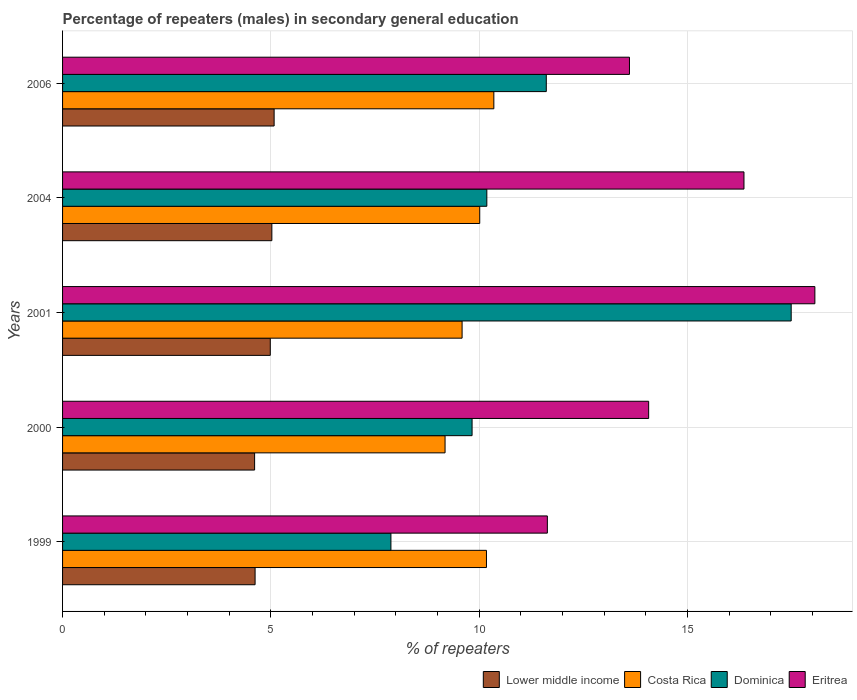How many groups of bars are there?
Your response must be concise. 5. Are the number of bars per tick equal to the number of legend labels?
Your answer should be very brief. Yes. How many bars are there on the 4th tick from the top?
Provide a short and direct response. 4. In how many cases, is the number of bars for a given year not equal to the number of legend labels?
Offer a terse response. 0. What is the percentage of male repeaters in Costa Rica in 2006?
Your response must be concise. 10.35. Across all years, what is the maximum percentage of male repeaters in Lower middle income?
Provide a short and direct response. 5.08. Across all years, what is the minimum percentage of male repeaters in Dominica?
Your answer should be very brief. 7.88. In which year was the percentage of male repeaters in Eritrea maximum?
Keep it short and to the point. 2001. What is the total percentage of male repeaters in Costa Rica in the graph?
Offer a terse response. 49.31. What is the difference between the percentage of male repeaters in Lower middle income in 2000 and that in 2006?
Provide a succinct answer. -0.47. What is the difference between the percentage of male repeaters in Costa Rica in 2006 and the percentage of male repeaters in Dominica in 2001?
Provide a succinct answer. -7.14. What is the average percentage of male repeaters in Costa Rica per year?
Ensure brevity in your answer.  9.86. In the year 1999, what is the difference between the percentage of male repeaters in Costa Rica and percentage of male repeaters in Dominica?
Keep it short and to the point. 2.29. In how many years, is the percentage of male repeaters in Lower middle income greater than 3 %?
Provide a succinct answer. 5. What is the ratio of the percentage of male repeaters in Lower middle income in 1999 to that in 2000?
Offer a very short reply. 1. Is the percentage of male repeaters in Dominica in 1999 less than that in 2006?
Provide a succinct answer. Yes. Is the difference between the percentage of male repeaters in Costa Rica in 1999 and 2000 greater than the difference between the percentage of male repeaters in Dominica in 1999 and 2000?
Your answer should be compact. Yes. What is the difference between the highest and the second highest percentage of male repeaters in Costa Rica?
Offer a terse response. 0.18. What is the difference between the highest and the lowest percentage of male repeaters in Costa Rica?
Provide a short and direct response. 1.17. What does the 4th bar from the bottom in 2000 represents?
Your answer should be compact. Eritrea. How many bars are there?
Keep it short and to the point. 20. Are all the bars in the graph horizontal?
Offer a terse response. Yes. How many years are there in the graph?
Keep it short and to the point. 5. What is the difference between two consecutive major ticks on the X-axis?
Ensure brevity in your answer.  5. Does the graph contain any zero values?
Your answer should be very brief. No. Does the graph contain grids?
Make the answer very short. Yes. What is the title of the graph?
Provide a succinct answer. Percentage of repeaters (males) in secondary general education. Does "Armenia" appear as one of the legend labels in the graph?
Offer a very short reply. No. What is the label or title of the X-axis?
Provide a short and direct response. % of repeaters. What is the label or title of the Y-axis?
Ensure brevity in your answer.  Years. What is the % of repeaters of Lower middle income in 1999?
Your response must be concise. 4.62. What is the % of repeaters in Costa Rica in 1999?
Make the answer very short. 10.17. What is the % of repeaters in Dominica in 1999?
Your response must be concise. 7.88. What is the % of repeaters of Eritrea in 1999?
Provide a short and direct response. 11.64. What is the % of repeaters in Lower middle income in 2000?
Offer a terse response. 4.61. What is the % of repeaters in Costa Rica in 2000?
Give a very brief answer. 9.18. What is the % of repeaters of Dominica in 2000?
Give a very brief answer. 9.83. What is the % of repeaters in Eritrea in 2000?
Make the answer very short. 14.07. What is the % of repeaters in Lower middle income in 2001?
Offer a very short reply. 4.99. What is the % of repeaters of Costa Rica in 2001?
Offer a terse response. 9.59. What is the % of repeaters of Dominica in 2001?
Your answer should be very brief. 17.49. What is the % of repeaters of Eritrea in 2001?
Offer a very short reply. 18.06. What is the % of repeaters of Lower middle income in 2004?
Provide a short and direct response. 5.02. What is the % of repeaters of Costa Rica in 2004?
Ensure brevity in your answer.  10.01. What is the % of repeaters of Dominica in 2004?
Give a very brief answer. 10.18. What is the % of repeaters in Eritrea in 2004?
Your answer should be compact. 16.35. What is the % of repeaters of Lower middle income in 2006?
Your response must be concise. 5.08. What is the % of repeaters in Costa Rica in 2006?
Your answer should be very brief. 10.35. What is the % of repeaters of Dominica in 2006?
Offer a very short reply. 11.61. What is the % of repeaters in Eritrea in 2006?
Provide a succinct answer. 13.61. Across all years, what is the maximum % of repeaters of Lower middle income?
Provide a succinct answer. 5.08. Across all years, what is the maximum % of repeaters of Costa Rica?
Your response must be concise. 10.35. Across all years, what is the maximum % of repeaters of Dominica?
Offer a terse response. 17.49. Across all years, what is the maximum % of repeaters of Eritrea?
Provide a succinct answer. 18.06. Across all years, what is the minimum % of repeaters in Lower middle income?
Give a very brief answer. 4.61. Across all years, what is the minimum % of repeaters in Costa Rica?
Your answer should be compact. 9.18. Across all years, what is the minimum % of repeaters of Dominica?
Your answer should be compact. 7.88. Across all years, what is the minimum % of repeaters of Eritrea?
Make the answer very short. 11.64. What is the total % of repeaters of Lower middle income in the graph?
Your response must be concise. 24.32. What is the total % of repeaters in Costa Rica in the graph?
Offer a very short reply. 49.31. What is the total % of repeaters in Dominica in the graph?
Ensure brevity in your answer.  56.99. What is the total % of repeaters of Eritrea in the graph?
Give a very brief answer. 73.72. What is the difference between the % of repeaters of Lower middle income in 1999 and that in 2000?
Make the answer very short. 0.01. What is the difference between the % of repeaters in Dominica in 1999 and that in 2000?
Provide a short and direct response. -1.95. What is the difference between the % of repeaters of Eritrea in 1999 and that in 2000?
Offer a terse response. -2.43. What is the difference between the % of repeaters in Lower middle income in 1999 and that in 2001?
Your response must be concise. -0.36. What is the difference between the % of repeaters of Costa Rica in 1999 and that in 2001?
Your answer should be very brief. 0.59. What is the difference between the % of repeaters in Dominica in 1999 and that in 2001?
Give a very brief answer. -9.61. What is the difference between the % of repeaters in Eritrea in 1999 and that in 2001?
Offer a terse response. -6.42. What is the difference between the % of repeaters in Lower middle income in 1999 and that in 2004?
Provide a short and direct response. -0.4. What is the difference between the % of repeaters of Costa Rica in 1999 and that in 2004?
Give a very brief answer. 0.16. What is the difference between the % of repeaters of Dominica in 1999 and that in 2004?
Offer a terse response. -2.3. What is the difference between the % of repeaters in Eritrea in 1999 and that in 2004?
Ensure brevity in your answer.  -4.72. What is the difference between the % of repeaters of Lower middle income in 1999 and that in 2006?
Provide a succinct answer. -0.46. What is the difference between the % of repeaters in Costa Rica in 1999 and that in 2006?
Keep it short and to the point. -0.18. What is the difference between the % of repeaters in Dominica in 1999 and that in 2006?
Provide a short and direct response. -3.73. What is the difference between the % of repeaters of Eritrea in 1999 and that in 2006?
Your answer should be very brief. -1.97. What is the difference between the % of repeaters in Lower middle income in 2000 and that in 2001?
Your response must be concise. -0.38. What is the difference between the % of repeaters of Costa Rica in 2000 and that in 2001?
Your answer should be compact. -0.41. What is the difference between the % of repeaters of Dominica in 2000 and that in 2001?
Ensure brevity in your answer.  -7.66. What is the difference between the % of repeaters in Eritrea in 2000 and that in 2001?
Offer a terse response. -3.99. What is the difference between the % of repeaters in Lower middle income in 2000 and that in 2004?
Provide a short and direct response. -0.41. What is the difference between the % of repeaters in Costa Rica in 2000 and that in 2004?
Provide a succinct answer. -0.83. What is the difference between the % of repeaters of Dominica in 2000 and that in 2004?
Make the answer very short. -0.35. What is the difference between the % of repeaters in Eritrea in 2000 and that in 2004?
Offer a terse response. -2.29. What is the difference between the % of repeaters of Lower middle income in 2000 and that in 2006?
Provide a succinct answer. -0.47. What is the difference between the % of repeaters in Costa Rica in 2000 and that in 2006?
Make the answer very short. -1.17. What is the difference between the % of repeaters of Dominica in 2000 and that in 2006?
Your answer should be very brief. -1.78. What is the difference between the % of repeaters of Eritrea in 2000 and that in 2006?
Provide a short and direct response. 0.46. What is the difference between the % of repeaters in Lower middle income in 2001 and that in 2004?
Your answer should be compact. -0.04. What is the difference between the % of repeaters in Costa Rica in 2001 and that in 2004?
Provide a succinct answer. -0.42. What is the difference between the % of repeaters of Dominica in 2001 and that in 2004?
Your answer should be compact. 7.3. What is the difference between the % of repeaters of Eritrea in 2001 and that in 2004?
Your answer should be very brief. 1.7. What is the difference between the % of repeaters in Lower middle income in 2001 and that in 2006?
Your answer should be compact. -0.09. What is the difference between the % of repeaters in Costa Rica in 2001 and that in 2006?
Offer a very short reply. -0.76. What is the difference between the % of repeaters of Dominica in 2001 and that in 2006?
Your answer should be very brief. 5.88. What is the difference between the % of repeaters of Eritrea in 2001 and that in 2006?
Give a very brief answer. 4.45. What is the difference between the % of repeaters in Lower middle income in 2004 and that in 2006?
Your response must be concise. -0.05. What is the difference between the % of repeaters in Costa Rica in 2004 and that in 2006?
Offer a terse response. -0.34. What is the difference between the % of repeaters in Dominica in 2004 and that in 2006?
Provide a short and direct response. -1.43. What is the difference between the % of repeaters of Eritrea in 2004 and that in 2006?
Offer a very short reply. 2.75. What is the difference between the % of repeaters in Lower middle income in 1999 and the % of repeaters in Costa Rica in 2000?
Make the answer very short. -4.56. What is the difference between the % of repeaters of Lower middle income in 1999 and the % of repeaters of Dominica in 2000?
Your answer should be compact. -5.21. What is the difference between the % of repeaters of Lower middle income in 1999 and the % of repeaters of Eritrea in 2000?
Your answer should be compact. -9.45. What is the difference between the % of repeaters of Costa Rica in 1999 and the % of repeaters of Dominica in 2000?
Give a very brief answer. 0.35. What is the difference between the % of repeaters in Costa Rica in 1999 and the % of repeaters in Eritrea in 2000?
Offer a terse response. -3.89. What is the difference between the % of repeaters of Dominica in 1999 and the % of repeaters of Eritrea in 2000?
Keep it short and to the point. -6.19. What is the difference between the % of repeaters in Lower middle income in 1999 and the % of repeaters in Costa Rica in 2001?
Your answer should be compact. -4.97. What is the difference between the % of repeaters of Lower middle income in 1999 and the % of repeaters of Dominica in 2001?
Offer a terse response. -12.87. What is the difference between the % of repeaters in Lower middle income in 1999 and the % of repeaters in Eritrea in 2001?
Your answer should be compact. -13.44. What is the difference between the % of repeaters in Costa Rica in 1999 and the % of repeaters in Dominica in 2001?
Provide a succinct answer. -7.31. What is the difference between the % of repeaters in Costa Rica in 1999 and the % of repeaters in Eritrea in 2001?
Offer a very short reply. -7.88. What is the difference between the % of repeaters of Dominica in 1999 and the % of repeaters of Eritrea in 2001?
Keep it short and to the point. -10.18. What is the difference between the % of repeaters in Lower middle income in 1999 and the % of repeaters in Costa Rica in 2004?
Provide a succinct answer. -5.39. What is the difference between the % of repeaters of Lower middle income in 1999 and the % of repeaters of Dominica in 2004?
Offer a terse response. -5.56. What is the difference between the % of repeaters of Lower middle income in 1999 and the % of repeaters of Eritrea in 2004?
Your response must be concise. -11.73. What is the difference between the % of repeaters in Costa Rica in 1999 and the % of repeaters in Dominica in 2004?
Provide a short and direct response. -0.01. What is the difference between the % of repeaters of Costa Rica in 1999 and the % of repeaters of Eritrea in 2004?
Provide a succinct answer. -6.18. What is the difference between the % of repeaters of Dominica in 1999 and the % of repeaters of Eritrea in 2004?
Ensure brevity in your answer.  -8.47. What is the difference between the % of repeaters in Lower middle income in 1999 and the % of repeaters in Costa Rica in 2006?
Give a very brief answer. -5.73. What is the difference between the % of repeaters of Lower middle income in 1999 and the % of repeaters of Dominica in 2006?
Keep it short and to the point. -6.99. What is the difference between the % of repeaters of Lower middle income in 1999 and the % of repeaters of Eritrea in 2006?
Your answer should be very brief. -8.99. What is the difference between the % of repeaters of Costa Rica in 1999 and the % of repeaters of Dominica in 2006?
Your answer should be compact. -1.44. What is the difference between the % of repeaters of Costa Rica in 1999 and the % of repeaters of Eritrea in 2006?
Provide a succinct answer. -3.43. What is the difference between the % of repeaters of Dominica in 1999 and the % of repeaters of Eritrea in 2006?
Keep it short and to the point. -5.73. What is the difference between the % of repeaters in Lower middle income in 2000 and the % of repeaters in Costa Rica in 2001?
Keep it short and to the point. -4.98. What is the difference between the % of repeaters in Lower middle income in 2000 and the % of repeaters in Dominica in 2001?
Offer a very short reply. -12.88. What is the difference between the % of repeaters of Lower middle income in 2000 and the % of repeaters of Eritrea in 2001?
Your answer should be very brief. -13.45. What is the difference between the % of repeaters in Costa Rica in 2000 and the % of repeaters in Dominica in 2001?
Offer a very short reply. -8.31. What is the difference between the % of repeaters of Costa Rica in 2000 and the % of repeaters of Eritrea in 2001?
Ensure brevity in your answer.  -8.88. What is the difference between the % of repeaters in Dominica in 2000 and the % of repeaters in Eritrea in 2001?
Your response must be concise. -8.23. What is the difference between the % of repeaters of Lower middle income in 2000 and the % of repeaters of Costa Rica in 2004?
Provide a short and direct response. -5.4. What is the difference between the % of repeaters of Lower middle income in 2000 and the % of repeaters of Dominica in 2004?
Keep it short and to the point. -5.57. What is the difference between the % of repeaters in Lower middle income in 2000 and the % of repeaters in Eritrea in 2004?
Your answer should be compact. -11.75. What is the difference between the % of repeaters in Costa Rica in 2000 and the % of repeaters in Dominica in 2004?
Your answer should be compact. -1. What is the difference between the % of repeaters in Costa Rica in 2000 and the % of repeaters in Eritrea in 2004?
Provide a succinct answer. -7.17. What is the difference between the % of repeaters in Dominica in 2000 and the % of repeaters in Eritrea in 2004?
Your response must be concise. -6.53. What is the difference between the % of repeaters of Lower middle income in 2000 and the % of repeaters of Costa Rica in 2006?
Provide a short and direct response. -5.74. What is the difference between the % of repeaters of Lower middle income in 2000 and the % of repeaters of Dominica in 2006?
Give a very brief answer. -7. What is the difference between the % of repeaters in Lower middle income in 2000 and the % of repeaters in Eritrea in 2006?
Your answer should be very brief. -9. What is the difference between the % of repeaters in Costa Rica in 2000 and the % of repeaters in Dominica in 2006?
Your answer should be compact. -2.43. What is the difference between the % of repeaters of Costa Rica in 2000 and the % of repeaters of Eritrea in 2006?
Offer a very short reply. -4.43. What is the difference between the % of repeaters of Dominica in 2000 and the % of repeaters of Eritrea in 2006?
Provide a succinct answer. -3.78. What is the difference between the % of repeaters in Lower middle income in 2001 and the % of repeaters in Costa Rica in 2004?
Provide a short and direct response. -5.03. What is the difference between the % of repeaters in Lower middle income in 2001 and the % of repeaters in Dominica in 2004?
Your answer should be compact. -5.2. What is the difference between the % of repeaters of Lower middle income in 2001 and the % of repeaters of Eritrea in 2004?
Make the answer very short. -11.37. What is the difference between the % of repeaters of Costa Rica in 2001 and the % of repeaters of Dominica in 2004?
Your answer should be compact. -0.59. What is the difference between the % of repeaters in Costa Rica in 2001 and the % of repeaters in Eritrea in 2004?
Provide a short and direct response. -6.77. What is the difference between the % of repeaters of Dominica in 2001 and the % of repeaters of Eritrea in 2004?
Provide a succinct answer. 1.13. What is the difference between the % of repeaters in Lower middle income in 2001 and the % of repeaters in Costa Rica in 2006?
Provide a short and direct response. -5.37. What is the difference between the % of repeaters of Lower middle income in 2001 and the % of repeaters of Dominica in 2006?
Give a very brief answer. -6.62. What is the difference between the % of repeaters in Lower middle income in 2001 and the % of repeaters in Eritrea in 2006?
Your answer should be compact. -8.62. What is the difference between the % of repeaters in Costa Rica in 2001 and the % of repeaters in Dominica in 2006?
Offer a very short reply. -2.02. What is the difference between the % of repeaters of Costa Rica in 2001 and the % of repeaters of Eritrea in 2006?
Give a very brief answer. -4.02. What is the difference between the % of repeaters in Dominica in 2001 and the % of repeaters in Eritrea in 2006?
Make the answer very short. 3.88. What is the difference between the % of repeaters in Lower middle income in 2004 and the % of repeaters in Costa Rica in 2006?
Give a very brief answer. -5.33. What is the difference between the % of repeaters in Lower middle income in 2004 and the % of repeaters in Dominica in 2006?
Keep it short and to the point. -6.59. What is the difference between the % of repeaters of Lower middle income in 2004 and the % of repeaters of Eritrea in 2006?
Offer a terse response. -8.58. What is the difference between the % of repeaters of Costa Rica in 2004 and the % of repeaters of Dominica in 2006?
Give a very brief answer. -1.6. What is the difference between the % of repeaters of Costa Rica in 2004 and the % of repeaters of Eritrea in 2006?
Offer a very short reply. -3.59. What is the difference between the % of repeaters of Dominica in 2004 and the % of repeaters of Eritrea in 2006?
Your answer should be compact. -3.42. What is the average % of repeaters of Lower middle income per year?
Keep it short and to the point. 4.86. What is the average % of repeaters in Costa Rica per year?
Provide a succinct answer. 9.86. What is the average % of repeaters in Dominica per year?
Your answer should be very brief. 11.4. What is the average % of repeaters of Eritrea per year?
Your answer should be very brief. 14.74. In the year 1999, what is the difference between the % of repeaters in Lower middle income and % of repeaters in Costa Rica?
Ensure brevity in your answer.  -5.55. In the year 1999, what is the difference between the % of repeaters of Lower middle income and % of repeaters of Dominica?
Give a very brief answer. -3.26. In the year 1999, what is the difference between the % of repeaters of Lower middle income and % of repeaters of Eritrea?
Give a very brief answer. -7.01. In the year 1999, what is the difference between the % of repeaters in Costa Rica and % of repeaters in Dominica?
Keep it short and to the point. 2.29. In the year 1999, what is the difference between the % of repeaters in Costa Rica and % of repeaters in Eritrea?
Provide a succinct answer. -1.46. In the year 1999, what is the difference between the % of repeaters of Dominica and % of repeaters of Eritrea?
Your answer should be very brief. -3.75. In the year 2000, what is the difference between the % of repeaters of Lower middle income and % of repeaters of Costa Rica?
Give a very brief answer. -4.57. In the year 2000, what is the difference between the % of repeaters of Lower middle income and % of repeaters of Dominica?
Give a very brief answer. -5.22. In the year 2000, what is the difference between the % of repeaters in Lower middle income and % of repeaters in Eritrea?
Provide a succinct answer. -9.46. In the year 2000, what is the difference between the % of repeaters in Costa Rica and % of repeaters in Dominica?
Your answer should be very brief. -0.65. In the year 2000, what is the difference between the % of repeaters in Costa Rica and % of repeaters in Eritrea?
Your response must be concise. -4.89. In the year 2000, what is the difference between the % of repeaters of Dominica and % of repeaters of Eritrea?
Your answer should be very brief. -4.24. In the year 2001, what is the difference between the % of repeaters of Lower middle income and % of repeaters of Costa Rica?
Your response must be concise. -4.6. In the year 2001, what is the difference between the % of repeaters in Lower middle income and % of repeaters in Dominica?
Keep it short and to the point. -12.5. In the year 2001, what is the difference between the % of repeaters in Lower middle income and % of repeaters in Eritrea?
Your answer should be very brief. -13.07. In the year 2001, what is the difference between the % of repeaters in Costa Rica and % of repeaters in Dominica?
Offer a very short reply. -7.9. In the year 2001, what is the difference between the % of repeaters in Costa Rica and % of repeaters in Eritrea?
Your answer should be compact. -8.47. In the year 2001, what is the difference between the % of repeaters in Dominica and % of repeaters in Eritrea?
Provide a succinct answer. -0.57. In the year 2004, what is the difference between the % of repeaters in Lower middle income and % of repeaters in Costa Rica?
Make the answer very short. -4.99. In the year 2004, what is the difference between the % of repeaters in Lower middle income and % of repeaters in Dominica?
Make the answer very short. -5.16. In the year 2004, what is the difference between the % of repeaters in Lower middle income and % of repeaters in Eritrea?
Provide a short and direct response. -11.33. In the year 2004, what is the difference between the % of repeaters in Costa Rica and % of repeaters in Dominica?
Ensure brevity in your answer.  -0.17. In the year 2004, what is the difference between the % of repeaters of Costa Rica and % of repeaters of Eritrea?
Keep it short and to the point. -6.34. In the year 2004, what is the difference between the % of repeaters in Dominica and % of repeaters in Eritrea?
Your answer should be very brief. -6.17. In the year 2006, what is the difference between the % of repeaters in Lower middle income and % of repeaters in Costa Rica?
Your answer should be compact. -5.27. In the year 2006, what is the difference between the % of repeaters of Lower middle income and % of repeaters of Dominica?
Give a very brief answer. -6.53. In the year 2006, what is the difference between the % of repeaters of Lower middle income and % of repeaters of Eritrea?
Offer a terse response. -8.53. In the year 2006, what is the difference between the % of repeaters in Costa Rica and % of repeaters in Dominica?
Give a very brief answer. -1.26. In the year 2006, what is the difference between the % of repeaters of Costa Rica and % of repeaters of Eritrea?
Your answer should be very brief. -3.25. In the year 2006, what is the difference between the % of repeaters of Dominica and % of repeaters of Eritrea?
Offer a terse response. -2. What is the ratio of the % of repeaters of Costa Rica in 1999 to that in 2000?
Your answer should be compact. 1.11. What is the ratio of the % of repeaters of Dominica in 1999 to that in 2000?
Your answer should be compact. 0.8. What is the ratio of the % of repeaters in Eritrea in 1999 to that in 2000?
Provide a succinct answer. 0.83. What is the ratio of the % of repeaters in Lower middle income in 1999 to that in 2001?
Provide a short and direct response. 0.93. What is the ratio of the % of repeaters of Costa Rica in 1999 to that in 2001?
Your answer should be compact. 1.06. What is the ratio of the % of repeaters in Dominica in 1999 to that in 2001?
Your response must be concise. 0.45. What is the ratio of the % of repeaters in Eritrea in 1999 to that in 2001?
Offer a very short reply. 0.64. What is the ratio of the % of repeaters of Lower middle income in 1999 to that in 2004?
Make the answer very short. 0.92. What is the ratio of the % of repeaters in Costa Rica in 1999 to that in 2004?
Ensure brevity in your answer.  1.02. What is the ratio of the % of repeaters of Dominica in 1999 to that in 2004?
Your answer should be compact. 0.77. What is the ratio of the % of repeaters of Eritrea in 1999 to that in 2004?
Your response must be concise. 0.71. What is the ratio of the % of repeaters in Lower middle income in 1999 to that in 2006?
Your answer should be compact. 0.91. What is the ratio of the % of repeaters of Costa Rica in 1999 to that in 2006?
Offer a very short reply. 0.98. What is the ratio of the % of repeaters in Dominica in 1999 to that in 2006?
Your response must be concise. 0.68. What is the ratio of the % of repeaters of Eritrea in 1999 to that in 2006?
Give a very brief answer. 0.86. What is the ratio of the % of repeaters in Lower middle income in 2000 to that in 2001?
Offer a very short reply. 0.92. What is the ratio of the % of repeaters in Costa Rica in 2000 to that in 2001?
Give a very brief answer. 0.96. What is the ratio of the % of repeaters in Dominica in 2000 to that in 2001?
Your answer should be very brief. 0.56. What is the ratio of the % of repeaters in Eritrea in 2000 to that in 2001?
Ensure brevity in your answer.  0.78. What is the ratio of the % of repeaters in Lower middle income in 2000 to that in 2004?
Your answer should be very brief. 0.92. What is the ratio of the % of repeaters in Costa Rica in 2000 to that in 2004?
Your response must be concise. 0.92. What is the ratio of the % of repeaters of Dominica in 2000 to that in 2004?
Give a very brief answer. 0.97. What is the ratio of the % of repeaters of Eritrea in 2000 to that in 2004?
Your response must be concise. 0.86. What is the ratio of the % of repeaters of Lower middle income in 2000 to that in 2006?
Provide a succinct answer. 0.91. What is the ratio of the % of repeaters of Costa Rica in 2000 to that in 2006?
Your response must be concise. 0.89. What is the ratio of the % of repeaters in Dominica in 2000 to that in 2006?
Give a very brief answer. 0.85. What is the ratio of the % of repeaters in Eritrea in 2000 to that in 2006?
Give a very brief answer. 1.03. What is the ratio of the % of repeaters in Costa Rica in 2001 to that in 2004?
Your answer should be very brief. 0.96. What is the ratio of the % of repeaters in Dominica in 2001 to that in 2004?
Offer a terse response. 1.72. What is the ratio of the % of repeaters of Eritrea in 2001 to that in 2004?
Keep it short and to the point. 1.1. What is the ratio of the % of repeaters of Lower middle income in 2001 to that in 2006?
Ensure brevity in your answer.  0.98. What is the ratio of the % of repeaters in Costa Rica in 2001 to that in 2006?
Your answer should be very brief. 0.93. What is the ratio of the % of repeaters of Dominica in 2001 to that in 2006?
Give a very brief answer. 1.51. What is the ratio of the % of repeaters in Eritrea in 2001 to that in 2006?
Offer a very short reply. 1.33. What is the ratio of the % of repeaters in Costa Rica in 2004 to that in 2006?
Your answer should be very brief. 0.97. What is the ratio of the % of repeaters of Dominica in 2004 to that in 2006?
Your response must be concise. 0.88. What is the ratio of the % of repeaters in Eritrea in 2004 to that in 2006?
Make the answer very short. 1.2. What is the difference between the highest and the second highest % of repeaters of Lower middle income?
Give a very brief answer. 0.05. What is the difference between the highest and the second highest % of repeaters of Costa Rica?
Your response must be concise. 0.18. What is the difference between the highest and the second highest % of repeaters of Dominica?
Provide a short and direct response. 5.88. What is the difference between the highest and the second highest % of repeaters of Eritrea?
Offer a very short reply. 1.7. What is the difference between the highest and the lowest % of repeaters in Lower middle income?
Ensure brevity in your answer.  0.47. What is the difference between the highest and the lowest % of repeaters in Costa Rica?
Ensure brevity in your answer.  1.17. What is the difference between the highest and the lowest % of repeaters in Dominica?
Provide a short and direct response. 9.61. What is the difference between the highest and the lowest % of repeaters in Eritrea?
Give a very brief answer. 6.42. 